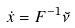Convert formula to latex. <formula><loc_0><loc_0><loc_500><loc_500>\dot { x } = F ^ { - 1 } \breve { \nu }</formula> 